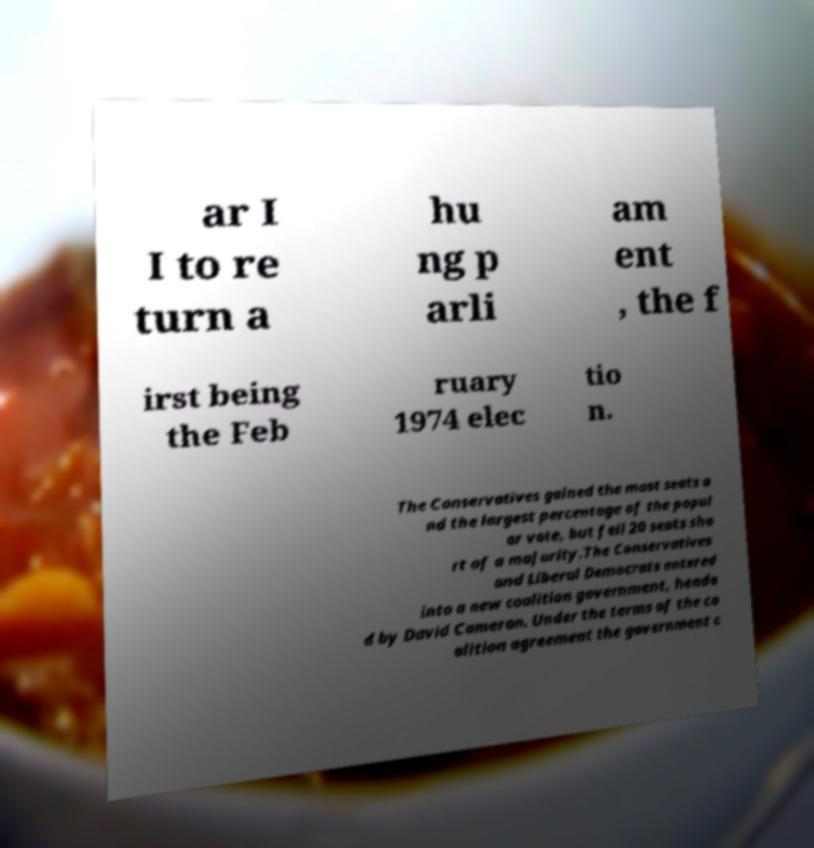Can you read and provide the text displayed in the image?This photo seems to have some interesting text. Can you extract and type it out for me? ar I I to re turn a hu ng p arli am ent , the f irst being the Feb ruary 1974 elec tio n. The Conservatives gained the most seats a nd the largest percentage of the popul ar vote, but fell 20 seats sho rt of a majority.The Conservatives and Liberal Democrats entered into a new coalition government, heade d by David Cameron. Under the terms of the co alition agreement the government c 